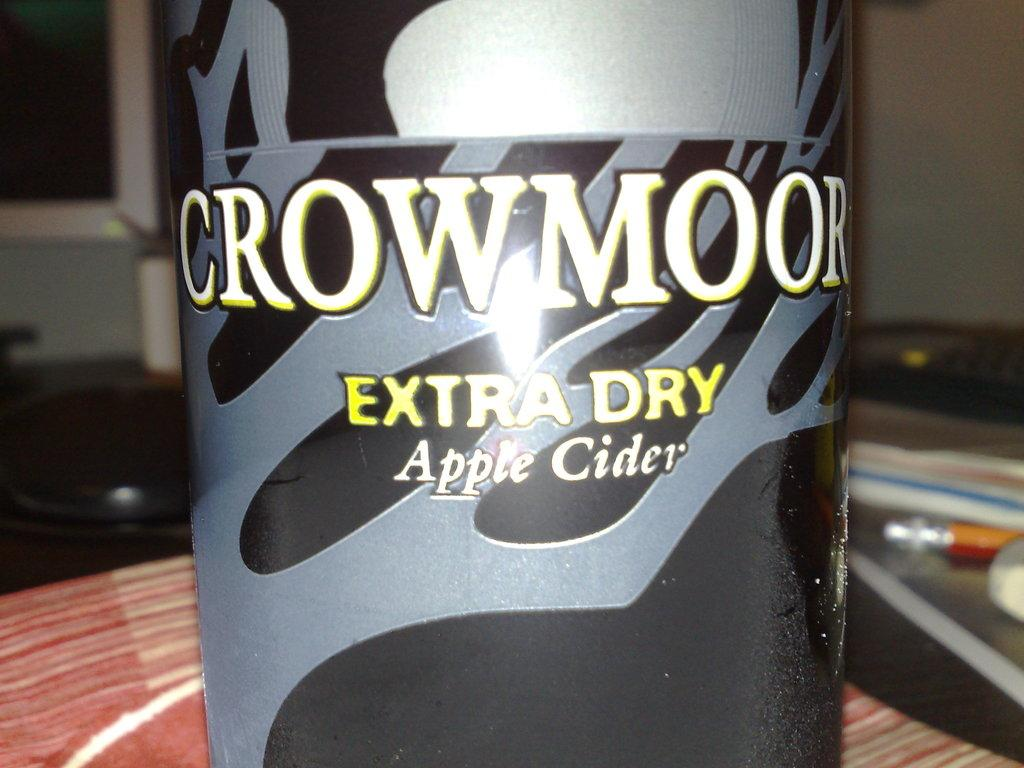What is the main object in the foreground of the image? There is a bottle in the foreground of the image. What else can be seen on the table in the foreground? There are objects on the table in the foreground of the image. What can be seen in the background of the image? There is a door and a wall in the background of the image. Can you describe the setting of the image? The image is likely taken in a room. What type of calculator is visible on the wall in the image? There is no calculator present in the image; it only features a bottle, objects on a table, a door, and a wall. 